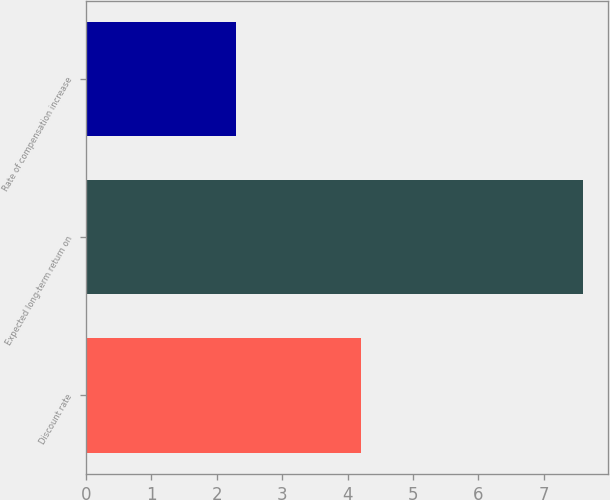Convert chart. <chart><loc_0><loc_0><loc_500><loc_500><bar_chart><fcel>Discount rate<fcel>Expected long-term return on<fcel>Rate of compensation increase<nl><fcel>4.2<fcel>7.6<fcel>2.3<nl></chart> 